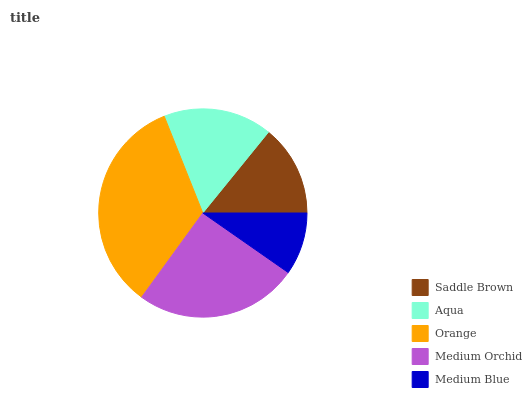Is Medium Blue the minimum?
Answer yes or no. Yes. Is Orange the maximum?
Answer yes or no. Yes. Is Aqua the minimum?
Answer yes or no. No. Is Aqua the maximum?
Answer yes or no. No. Is Aqua greater than Saddle Brown?
Answer yes or no. Yes. Is Saddle Brown less than Aqua?
Answer yes or no. Yes. Is Saddle Brown greater than Aqua?
Answer yes or no. No. Is Aqua less than Saddle Brown?
Answer yes or no. No. Is Aqua the high median?
Answer yes or no. Yes. Is Aqua the low median?
Answer yes or no. Yes. Is Orange the high median?
Answer yes or no. No. Is Medium Orchid the low median?
Answer yes or no. No. 